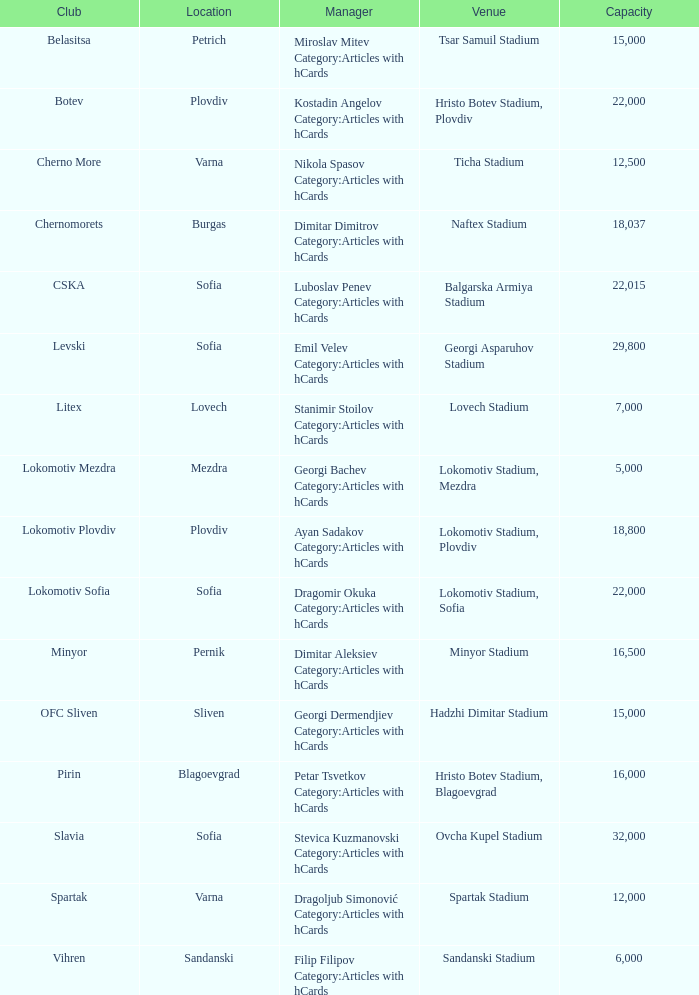What is the highest capacity for the venue, ticha stadium, located in varna? 12500.0. Write the full table. {'header': ['Club', 'Location', 'Manager', 'Venue', 'Capacity'], 'rows': [['Belasitsa', 'Petrich', 'Miroslav Mitev Category:Articles with hCards', 'Tsar Samuil Stadium', '15,000'], ['Botev', 'Plovdiv', 'Kostadin Angelov Category:Articles with hCards', 'Hristo Botev Stadium, Plovdiv', '22,000'], ['Cherno More', 'Varna', 'Nikola Spasov Category:Articles with hCards', 'Ticha Stadium', '12,500'], ['Chernomorets', 'Burgas', 'Dimitar Dimitrov Category:Articles with hCards', 'Naftex Stadium', '18,037'], ['CSKA', 'Sofia', 'Luboslav Penev Category:Articles with hCards', 'Balgarska Armiya Stadium', '22,015'], ['Levski', 'Sofia', 'Emil Velev Category:Articles with hCards', 'Georgi Asparuhov Stadium', '29,800'], ['Litex', 'Lovech', 'Stanimir Stoilov Category:Articles with hCards', 'Lovech Stadium', '7,000'], ['Lokomotiv Mezdra', 'Mezdra', 'Georgi Bachev Category:Articles with hCards', 'Lokomotiv Stadium, Mezdra', '5,000'], ['Lokomotiv Plovdiv', 'Plovdiv', 'Ayan Sadakov Category:Articles with hCards', 'Lokomotiv Stadium, Plovdiv', '18,800'], ['Lokomotiv Sofia', 'Sofia', 'Dragomir Okuka Category:Articles with hCards', 'Lokomotiv Stadium, Sofia', '22,000'], ['Minyor', 'Pernik', 'Dimitar Aleksiev Category:Articles with hCards', 'Minyor Stadium', '16,500'], ['OFC Sliven', 'Sliven', 'Georgi Dermendjiev Category:Articles with hCards', 'Hadzhi Dimitar Stadium', '15,000'], ['Pirin', 'Blagoevgrad', 'Petar Tsvetkov Category:Articles with hCards', 'Hristo Botev Stadium, Blagoevgrad', '16,000'], ['Slavia', 'Sofia', 'Stevica Kuzmanovski Category:Articles with hCards', 'Ovcha Kupel Stadium', '32,000'], ['Spartak', 'Varna', 'Dragoljub Simonović Category:Articles with hCards', 'Spartak Stadium', '12,000'], ['Vihren', 'Sandanski', 'Filip Filipov Category:Articles with hCards', 'Sandanski Stadium', '6,000']]} 